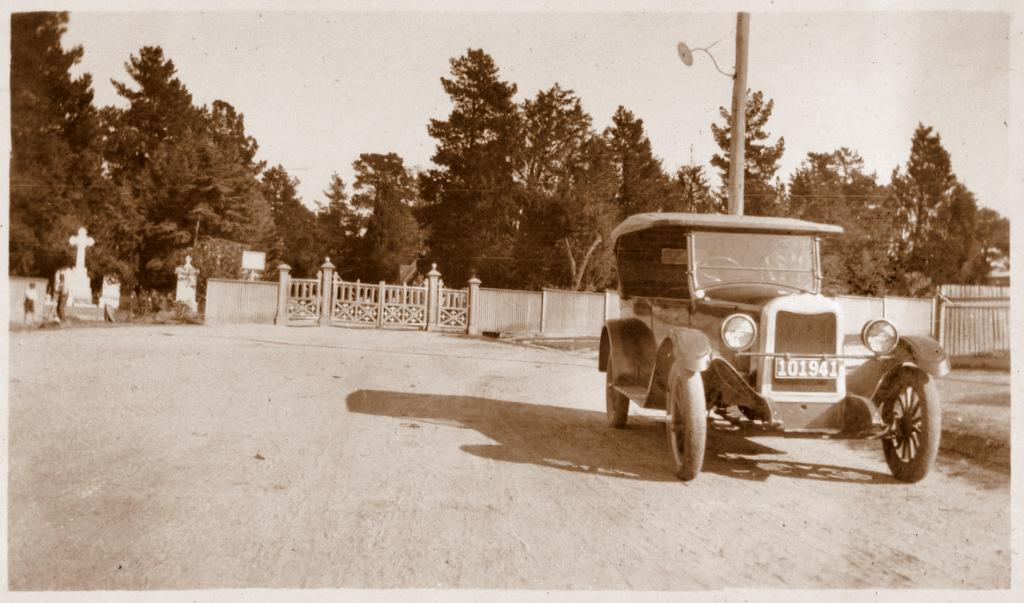What vehicle is located on the right side of the image? There is a jeep on the right side of the image. What can be seen in the background of the image? There is a boundary, trees, and headstones in the background of the image. How many facts can be seen with the eyes in the image? There is no reference to facts or eyes in the image, so it is not possible to answer that question. 